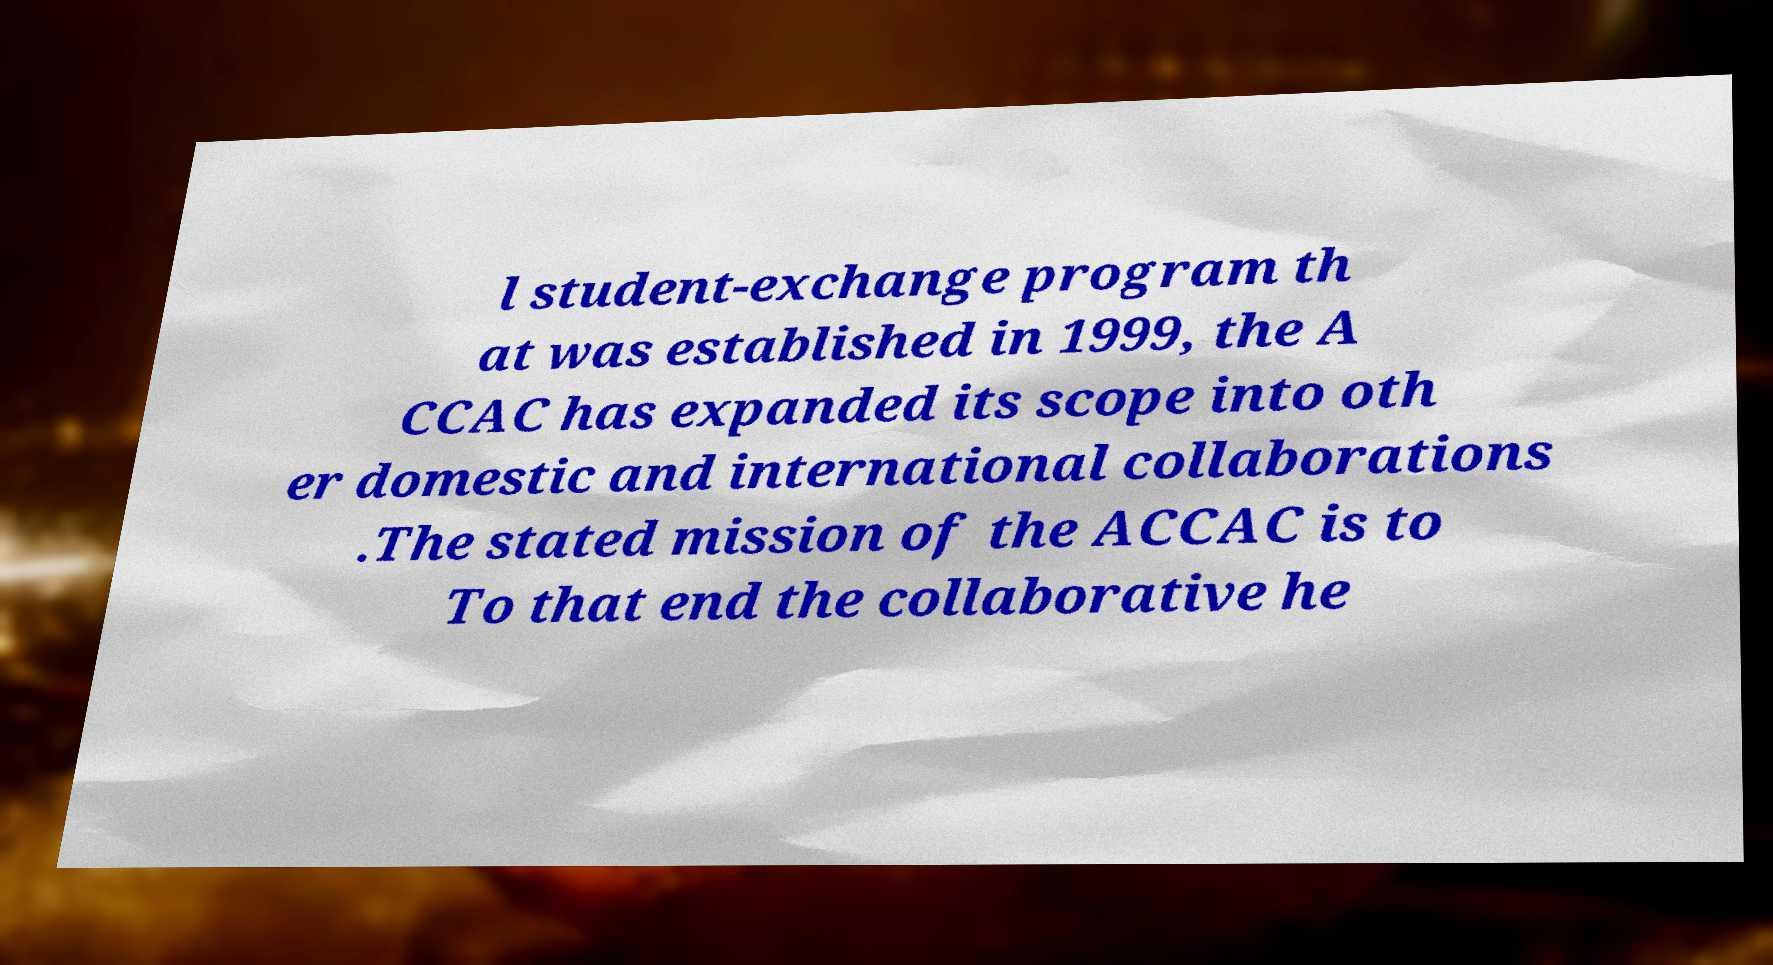What messages or text are displayed in this image? I need them in a readable, typed format. l student-exchange program th at was established in 1999, the A CCAC has expanded its scope into oth er domestic and international collaborations .The stated mission of the ACCAC is to To that end the collaborative he 